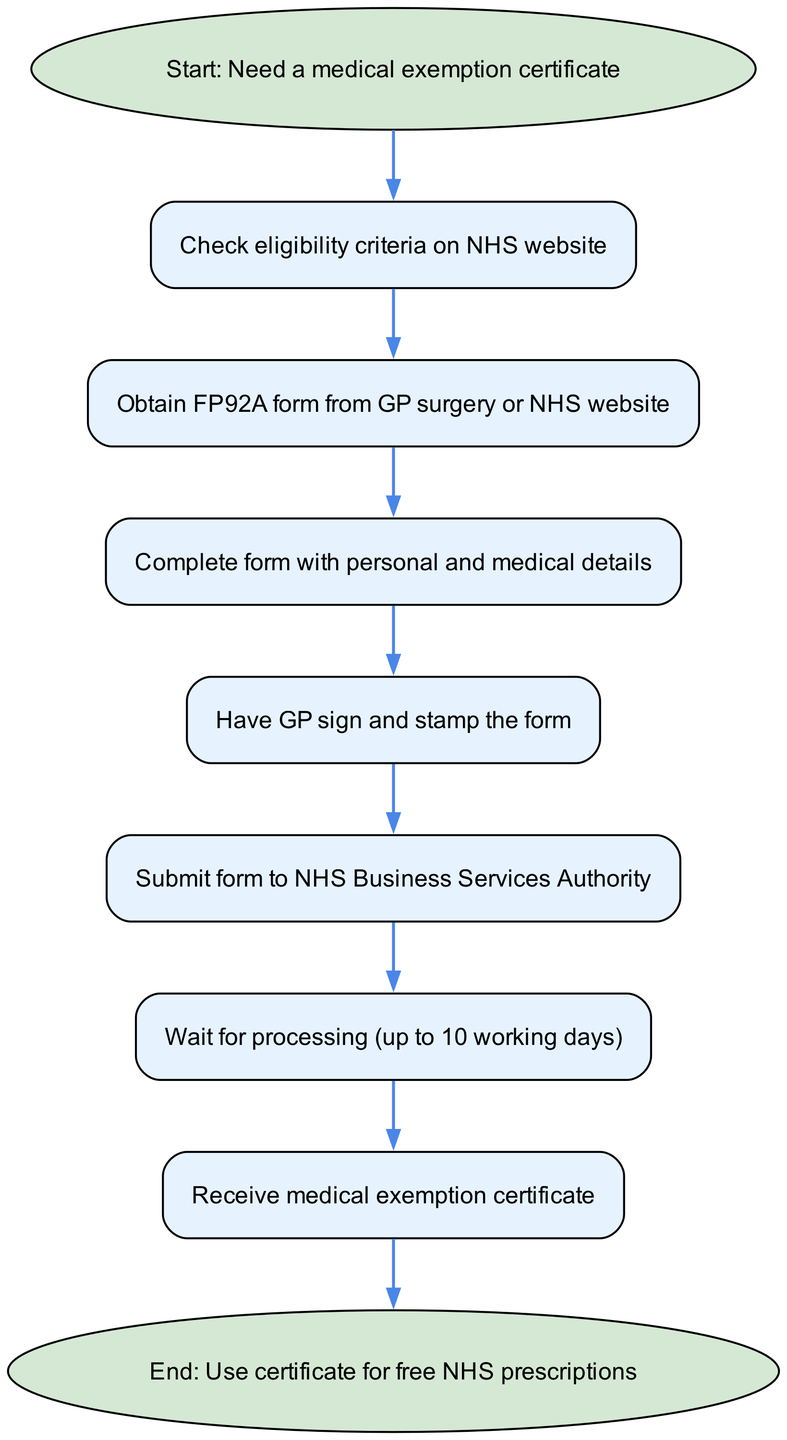What is the first action in the process? The first action in the diagram is represented by the node labeled "Start: Need a medical exemption certificate," which is the initiating step in the flowchart.
Answer: Start: Need a medical exemption certificate How many nodes are there in total? Counting all the unique nodes listed in the diagram, there are 9 nodes, including the start and end.
Answer: 9 What action follows checking eligibility? After checking eligibility, the next action specified in the diagram is "Obtain FP92A form from GP surgery or NHS website." This is the subsequent step in the flow of the process.
Answer: Obtain FP92A form from GP surgery or NHS website What is needed after completing the form? According to the diagram, after completing the form, the next step is to "Have GP sign and stamp the form." This indicates that the form requires a signature and stamp from a GP to move forward.
Answer: Have GP sign and stamp the form What is the outcome after receiving the certificate? The final step in the flowchart states "End: Use certificate for free NHS prescriptions." This indicates that the outcome of receiving the certificate allows the person to utilize it for obtaining free NHS prescriptions.
Answer: Use certificate for free NHS prescriptions What is the maximum waiting time after submitting the form? The diagram specifies that after submitting the form, the waiting time for processing is "up to 10 working days," which informs applicants of the longest possible duration they should expect for processing.
Answer: up to 10 working days What is the significance of the "Submit form" step? The "Submit form to NHS Business Services Authority" step is crucial as it indicates that the completed FP92A form must be sent to the appropriate authority to officially apply for the medical exemption certificate.
Answer: Submit form to NHS Business Services Authority Which step follows obtaining the form? After obtaining the FP92A form, the next logical step is "Complete form with personal and medical details" as per the flow of the process laid out in the diagram.
Answer: Complete form with personal and medical details 